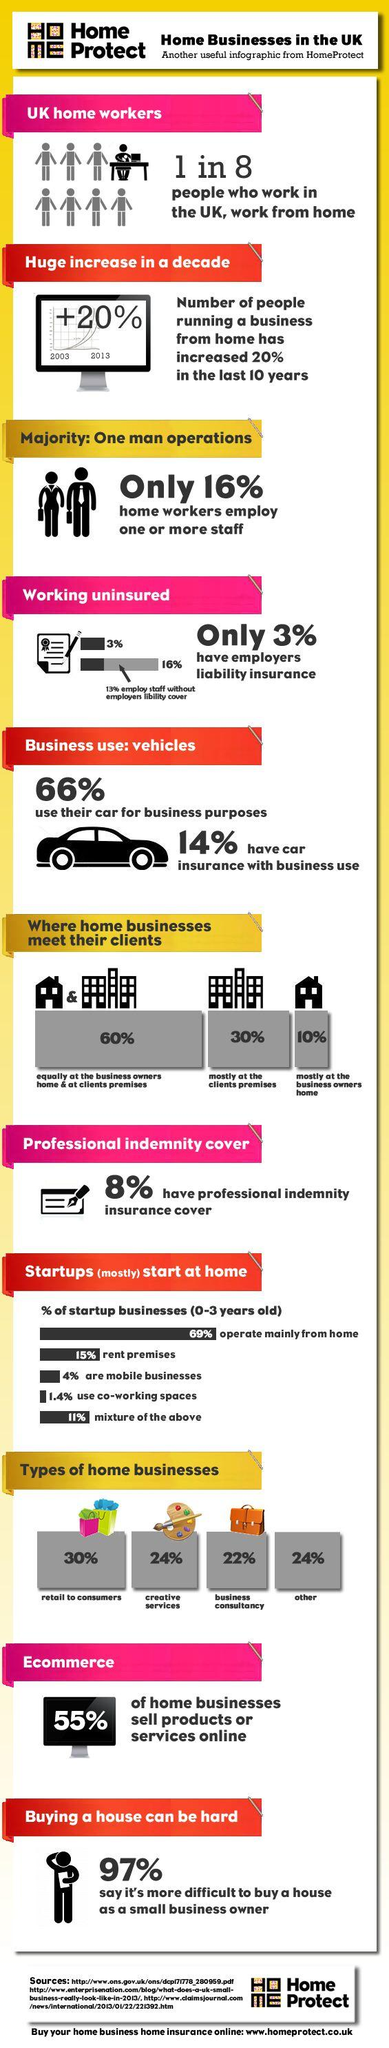Outline some significant characteristics in this image. According to a recent survey, approximately 45% of home businesses in the UK do not sell any online products or services. According to a recent study, only 10% of home businesses in the UK meet their clients primarily at the business owner's home. According to a recent study, 24% of home businesses in the UK are in the creative services industry. According to a recent survey, approximately 22% of home businesses in the UK are in the business consultancy sector. According to a recent survey, only 1.4% of startup businesses in the UK utilize co-working spaces. 